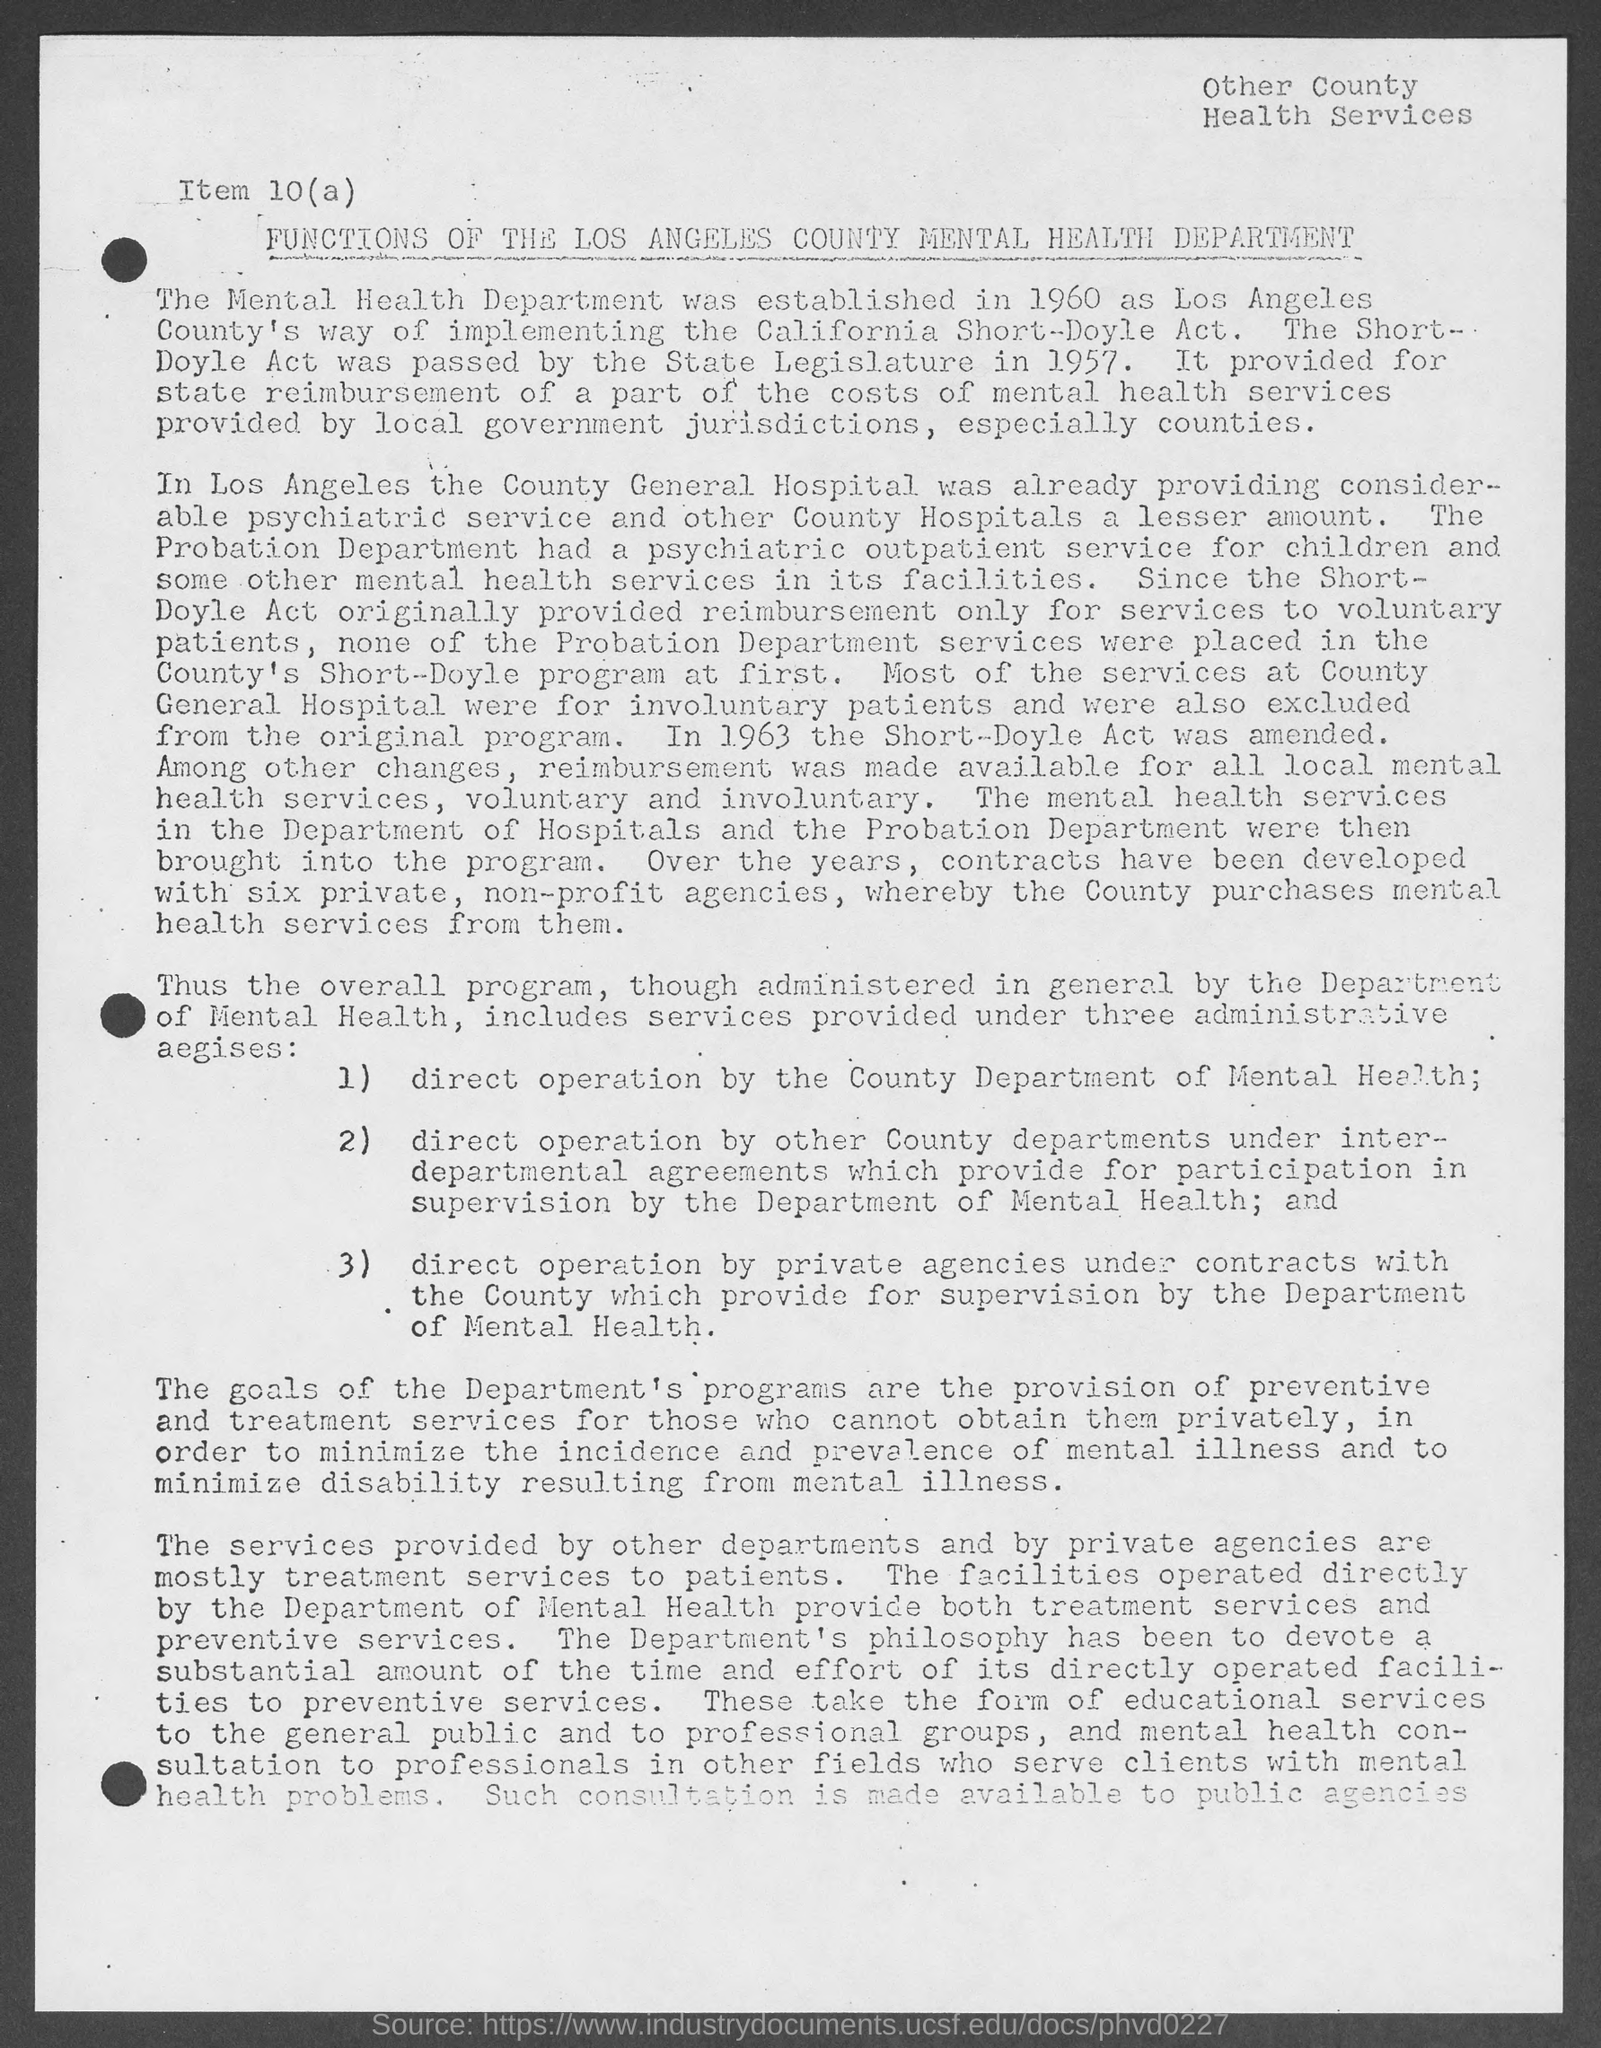Which year "The Mental Health Department" was established?
Ensure brevity in your answer.  1960. Which year State Legislature has passed "The Short-Doyle Act"?
Your answer should be compact. 1957. Which "department had a psychiatric outpatient service for children"?
Provide a succinct answer. Probation department. "Most of the services at County General Hospital were for whom?
Offer a terse response. Involuntary patients. In which year "the Short-Doyle Act" was amended?
Offer a terse response. 1963. The Short-Doyle Act originally provided reimbursement of services to which category of patients?
Provide a short and direct response. Voluntary Patients. 